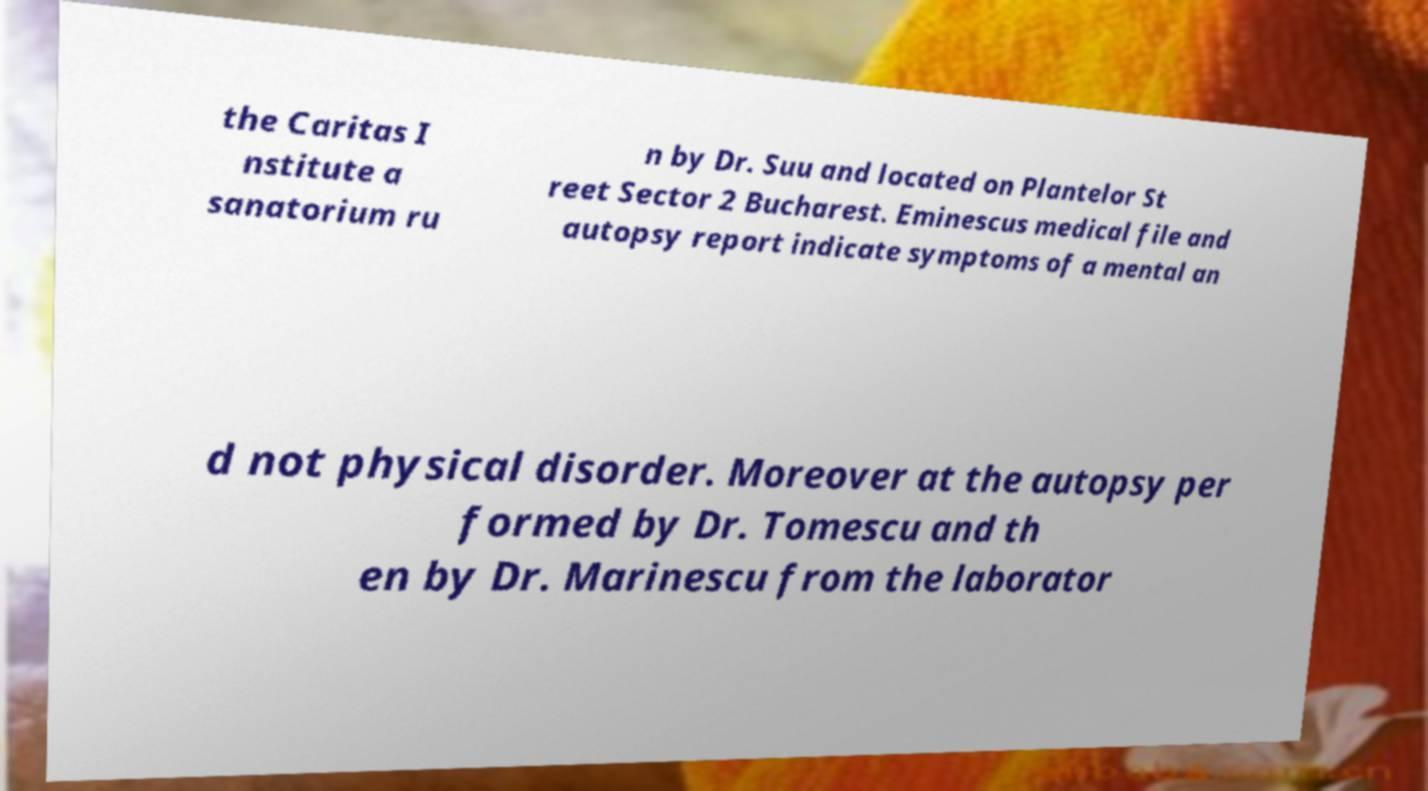I need the written content from this picture converted into text. Can you do that? the Caritas I nstitute a sanatorium ru n by Dr. Suu and located on Plantelor St reet Sector 2 Bucharest. Eminescus medical file and autopsy report indicate symptoms of a mental an d not physical disorder. Moreover at the autopsy per formed by Dr. Tomescu and th en by Dr. Marinescu from the laborator 